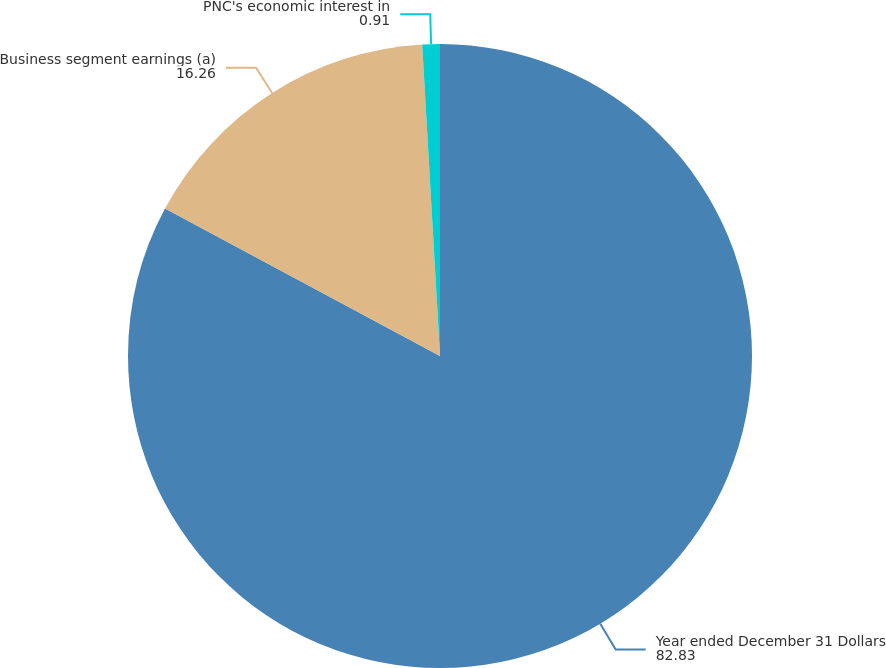<chart> <loc_0><loc_0><loc_500><loc_500><pie_chart><fcel>Year ended December 31 Dollars<fcel>Business segment earnings (a)<fcel>PNC's economic interest in<nl><fcel>82.83%<fcel>16.26%<fcel>0.91%<nl></chart> 